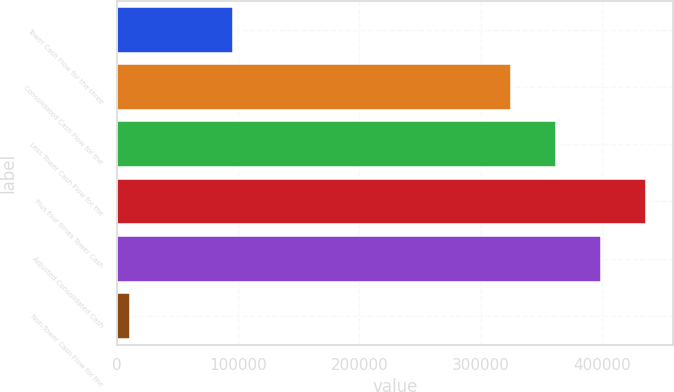Convert chart. <chart><loc_0><loc_0><loc_500><loc_500><bar_chart><fcel>Tower Cash Flow for the three<fcel>Consolidated Cash Flow for the<fcel>Less Tower Cash Flow for the<fcel>Plus four times Tower Cash<fcel>Adjusted Consolidated Cash<fcel>Non-Tower Cash Flow for the<nl><fcel>95933<fcel>324676<fcel>361990<fcel>436618<fcel>399304<fcel>10591<nl></chart> 